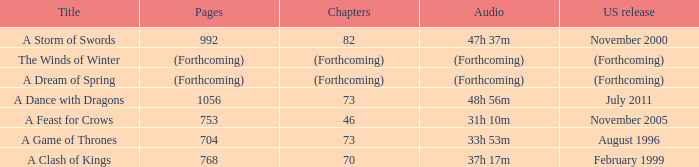Which US release has 704 pages? August 1996. Can you give me this table as a dict? {'header': ['Title', 'Pages', 'Chapters', 'Audio', 'US release'], 'rows': [['A Storm of Swords', '992', '82', '47h 37m', 'November 2000'], ['The Winds of Winter', '(Forthcoming)', '(Forthcoming)', '(Forthcoming)', '(Forthcoming)'], ['A Dream of Spring', '(Forthcoming)', '(Forthcoming)', '(Forthcoming)', '(Forthcoming)'], ['A Dance with Dragons', '1056', '73', '48h 56m', 'July 2011'], ['A Feast for Crows', '753', '46', '31h 10m', 'November 2005'], ['A Game of Thrones', '704', '73', '33h 53m', 'August 1996'], ['A Clash of Kings', '768', '70', '37h 17m', 'February 1999']]} 